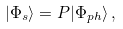<formula> <loc_0><loc_0><loc_500><loc_500>| \Phi _ { s } \rangle = P | \Phi _ { p h } \rangle \, ,</formula> 